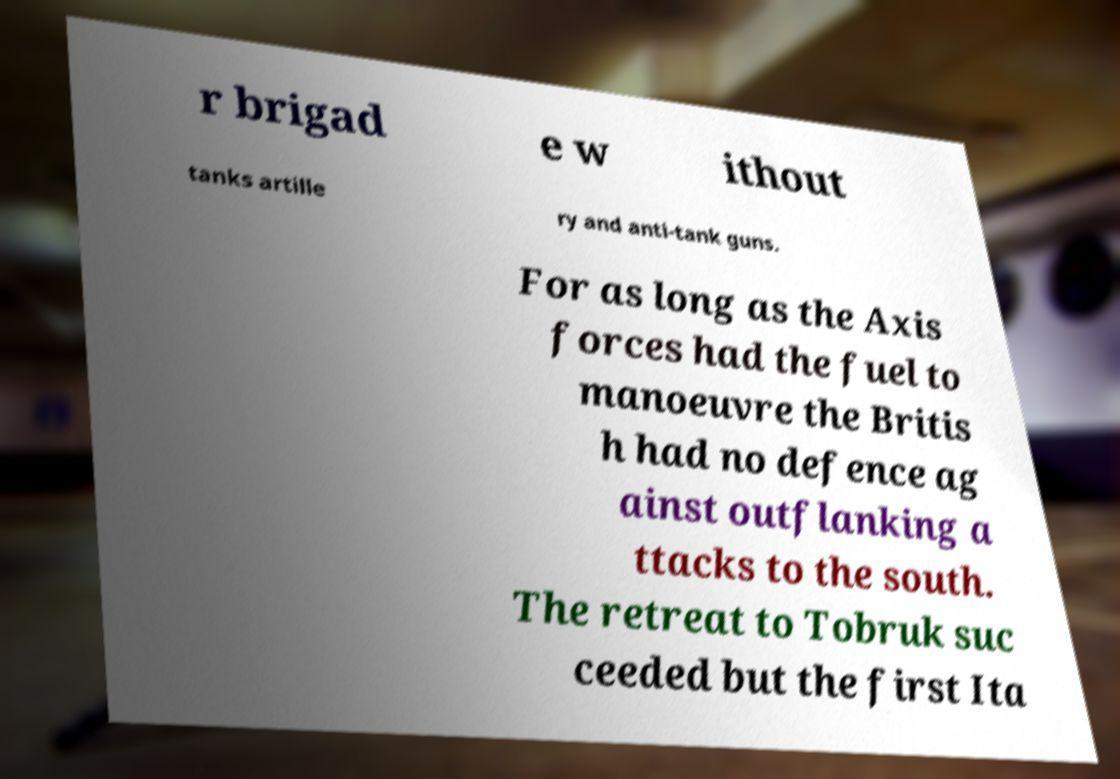Please read and relay the text visible in this image. What does it say? r brigad e w ithout tanks artille ry and anti-tank guns. For as long as the Axis forces had the fuel to manoeuvre the Britis h had no defence ag ainst outflanking a ttacks to the south. The retreat to Tobruk suc ceeded but the first Ita 